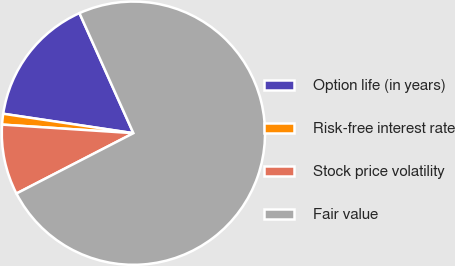<chart> <loc_0><loc_0><loc_500><loc_500><pie_chart><fcel>Option life (in years)<fcel>Risk-free interest rate<fcel>Stock price volatility<fcel>Fair value<nl><fcel>15.92%<fcel>1.32%<fcel>8.62%<fcel>74.14%<nl></chart> 